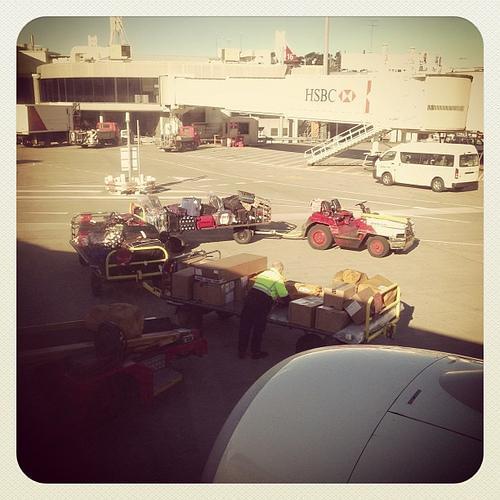How many men?
Give a very brief answer. 1. 